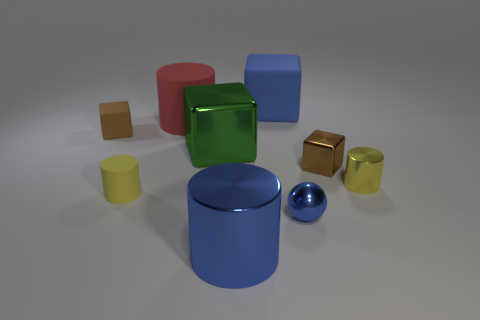Which object stands out the most due to its size and color? The large blue cylinder in the center of the image instantly draws attention due to its size and the vibrant shade of blue that distinguishes it from the other objects. 